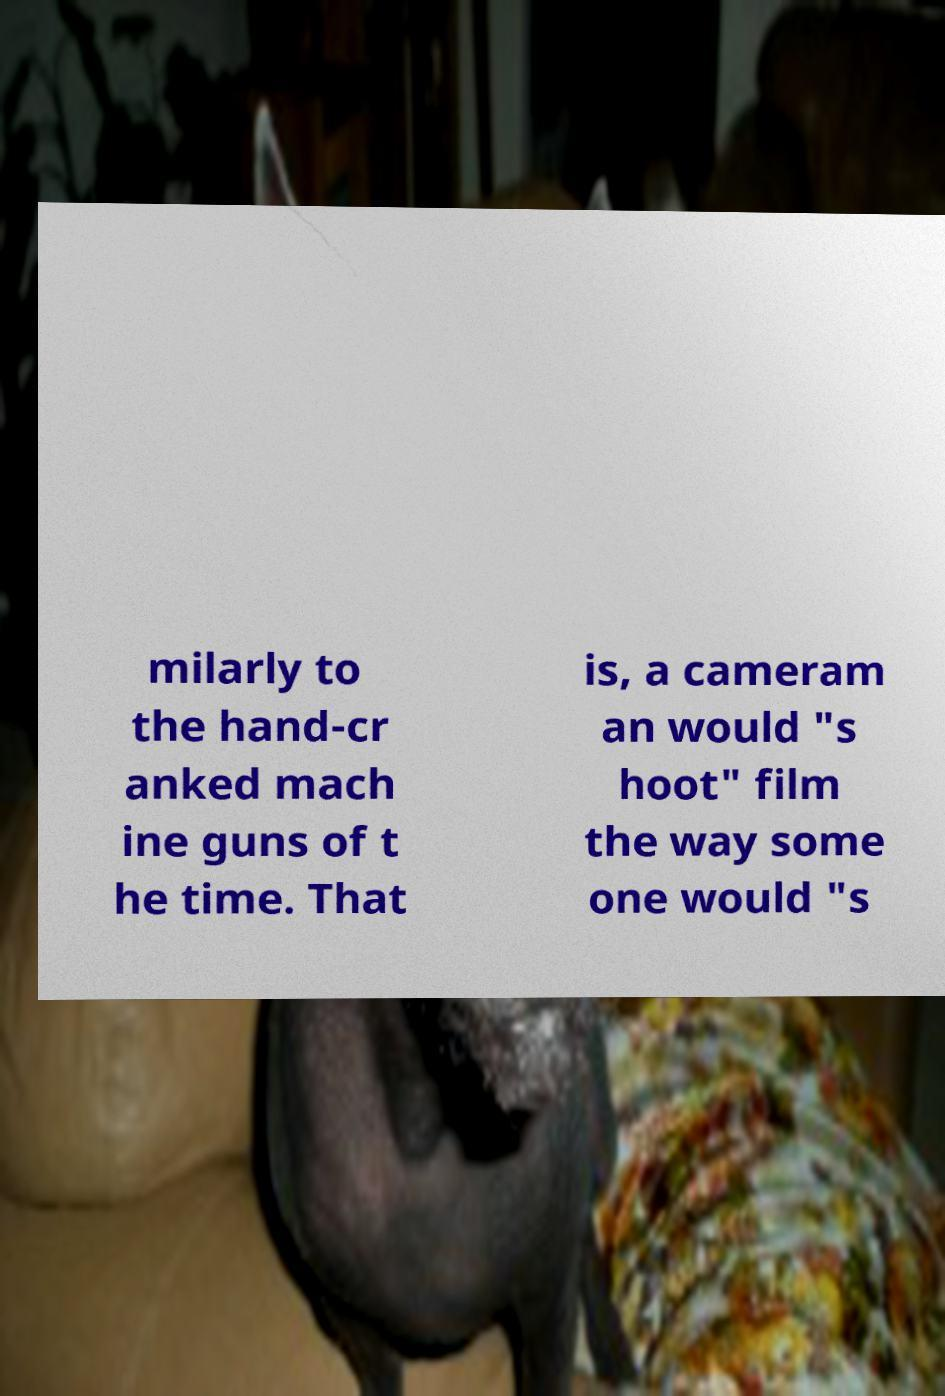What messages or text are displayed in this image? I need them in a readable, typed format. milarly to the hand-cr anked mach ine guns of t he time. That is, a cameram an would "s hoot" film the way some one would "s 